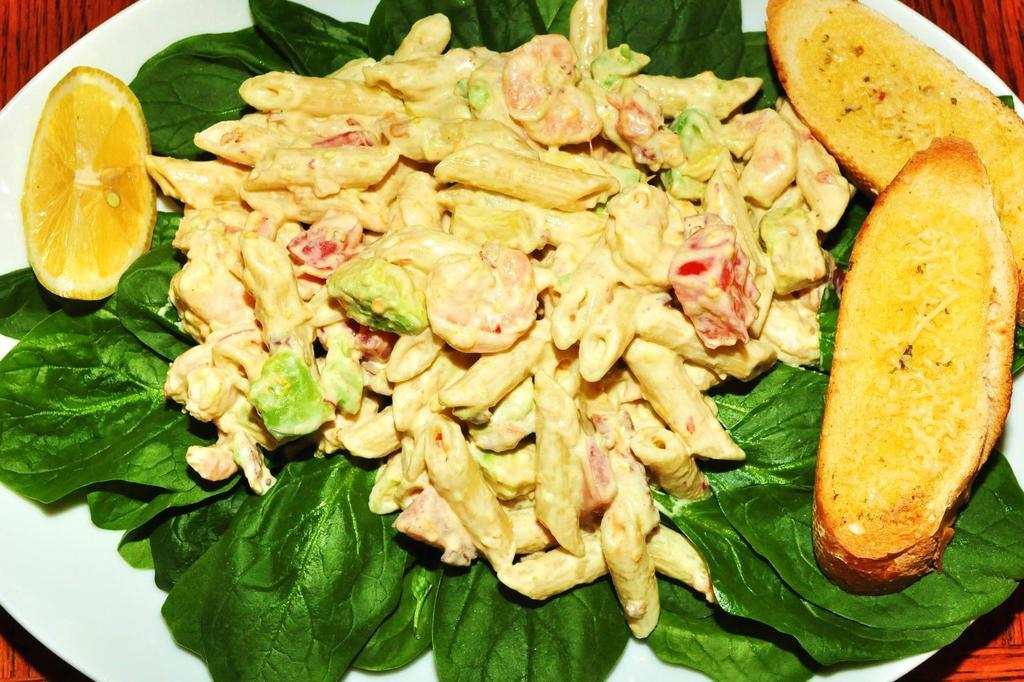What is on the plate that is visible in the image? There is a plate of food items in the image. What other items can be seen in the image besides the plate of food? There are leaves in the image. What type of surface is the plate placed on? The plate is placed on a wooden surface. What type of haircut does the cattle have in the image? There is no cattle present in the image, and therefore no haircut can be observed. 